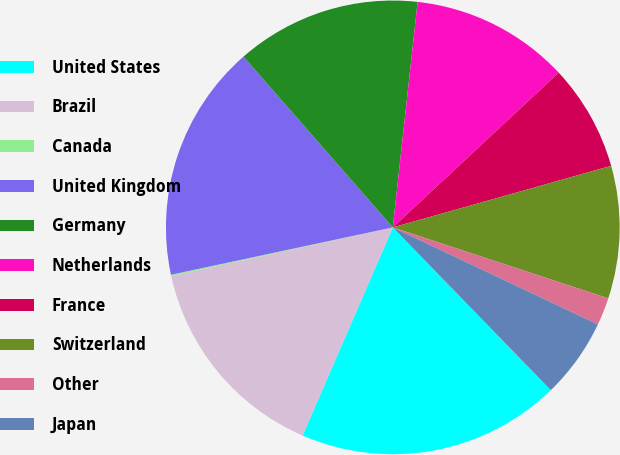<chart> <loc_0><loc_0><loc_500><loc_500><pie_chart><fcel>United States<fcel>Brazil<fcel>Canada<fcel>United Kingdom<fcel>Germany<fcel>Netherlands<fcel>France<fcel>Switzerland<fcel>Other<fcel>Japan<nl><fcel>18.78%<fcel>15.04%<fcel>0.1%<fcel>16.91%<fcel>13.18%<fcel>11.31%<fcel>7.57%<fcel>9.44%<fcel>1.97%<fcel>5.7%<nl></chart> 